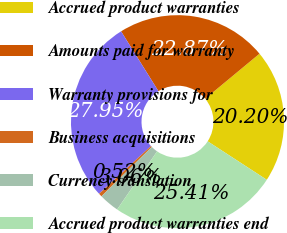<chart> <loc_0><loc_0><loc_500><loc_500><pie_chart><fcel>Accrued product warranties<fcel>Amounts paid for warranty<fcel>Warranty provisions for<fcel>Business acquisitions<fcel>Currency translation<fcel>Accrued product warranties end<nl><fcel>20.2%<fcel>22.87%<fcel>27.95%<fcel>0.52%<fcel>3.06%<fcel>25.41%<nl></chart> 